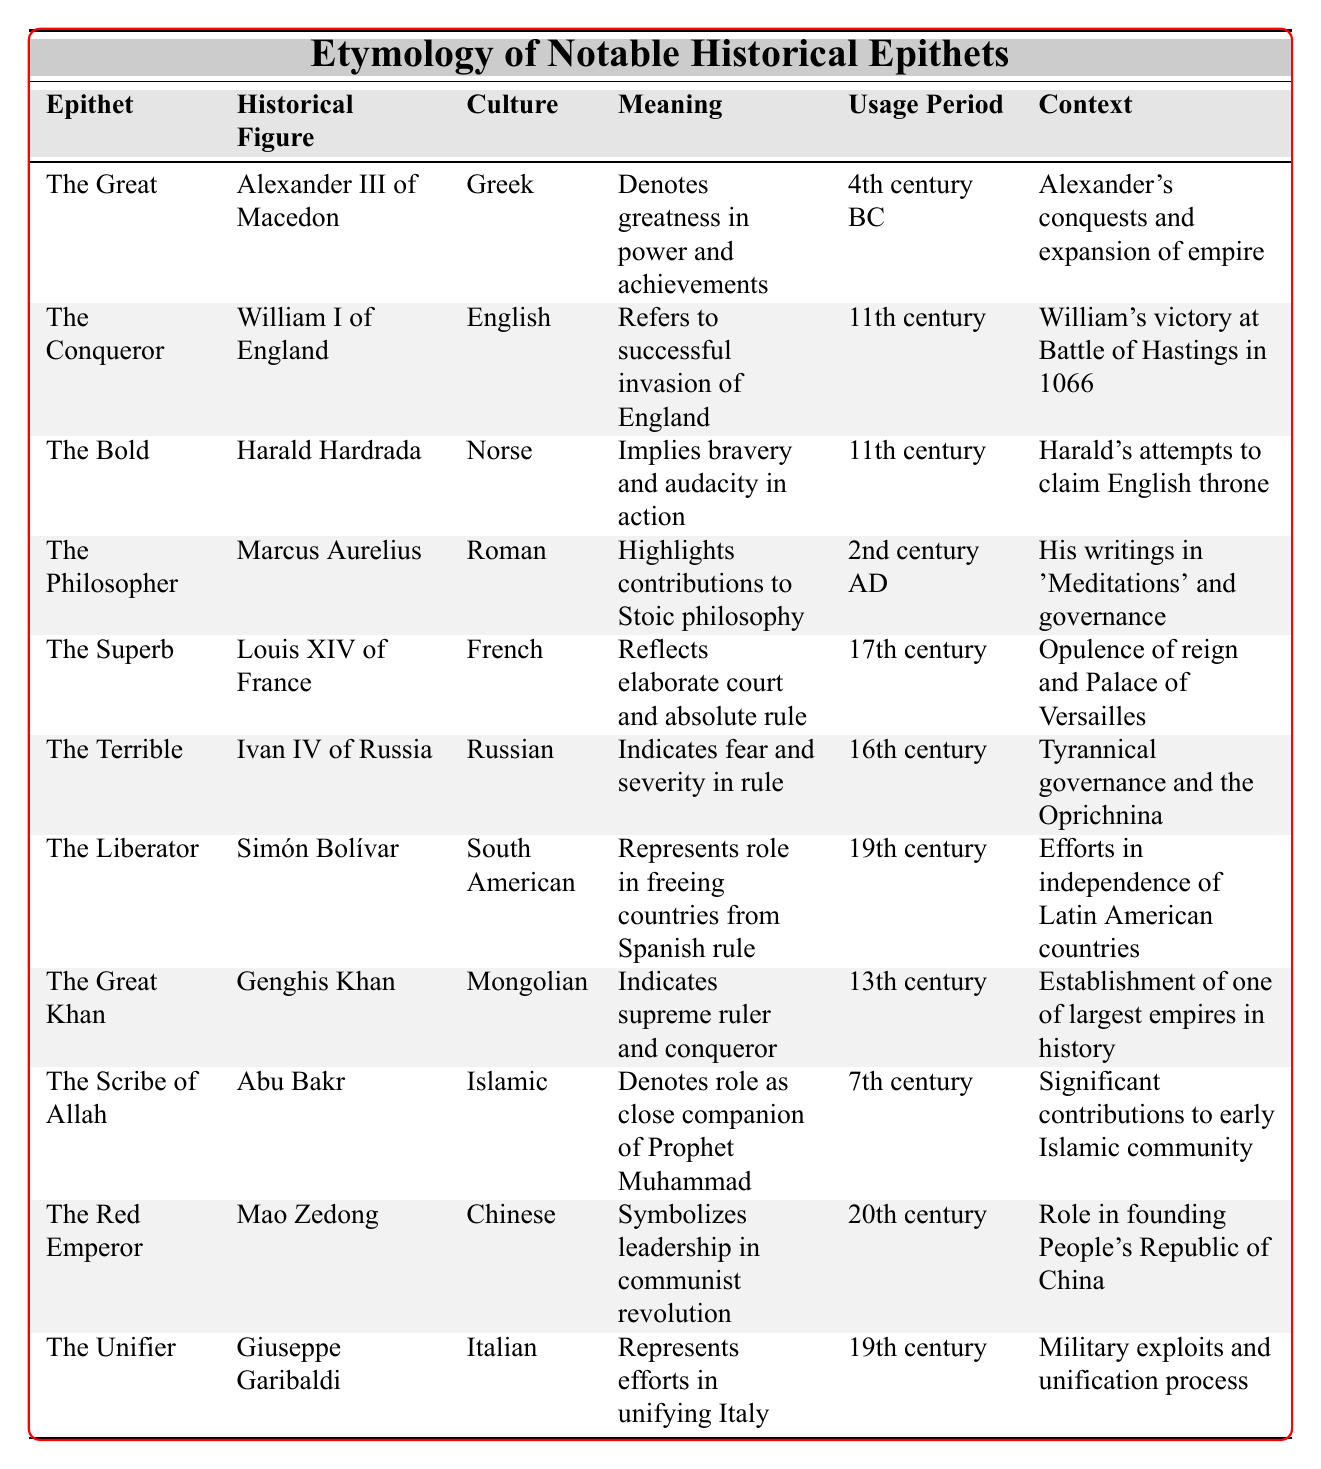What is the epithet associated with Alexander III of Macedon? The table shows that Alexander III of Macedon is associated with the epithet "The Great."
Answer: The Great Which culture is associated with the epithet "The Terrible"? The table indicates that the epithet "The Terrible" is associated with Russian culture, specifically in relation to Ivan IV of Russia.
Answer: Russian What does the epithet "The Unifier" mean? According to the table, "The Unifier" represents Giuseppe Garibaldi's efforts in unifying Italy.
Answer: Efforts in unifying Italy How many epithets are listed in the table? By counting the rows in the table, there are a total of 10 epithets listed.
Answer: 10 Which historical figure's epithet reflects his contributions to Stoic philosophy? The table specifies that Marcus Aurelius is known as "The Philosopher," which reflects his contributions to Stoic philosophy.
Answer: Marcus Aurelius Is "The Red Emperor" associated with a 20th-century historical figure? The table shows that "The Red Emperor" refers to Mao Zedong, and he is indeed a 20th-century historical figure.
Answer: Yes What is the meaning of "The Philopher"? The epithet "The Philosopher" highlights Marcus Aurelius' contributions to Stoic philosophy, as indicated in the table.
Answer: Contributions to Stoic philosophy Which two epithets are associated with figures from the 11th century? The table lists "The Conqueror" for William I of England and "The Bold" for Harald Hardrada as the two epithets from the 11th century.
Answer: The Conqueror, The Bold What is the context for the epithet "The Superb"? The context provided in the table shows that "The Superb" refers to the opulence of Louis XIV's reign and the Palace of Versailles.
Answer: Opulence of Louis XIV's reign Who was referred to as "The Liberator"? The table indicates that Simón Bolívar was referred to as "The Liberator," due to his role in freeing multiple countries from Spanish rule.
Answer: Simón Bolívar What does "The Great Khan" imply about Genghis Khan? According to the table, "The Great Khan" indicates that Genghis Khan was seen as a supreme ruler and conqueror, reflecting his historical significance.
Answer: Supreme ruler and conqueror Which epithet is associated with a close companion of the Prophet Muhammad? "The Scribe of Allah" is the epithet associated with Abu Bakr, noted as a close companion of the Prophet Muhammad in the table.
Answer: The Scribe of Allah How many epithets listed are from the 19th century? Based on the table, there are three epithets associated with the 19th century: "The Liberator," "The Unifier," and Simón Bolívar's efforts in Latin America's independence.
Answer: 3 Is "The Bold" associated with a Norse historical figure? Yes, the table confirms that "The Bold" refers to Harald Hardrada, a Norse historical figure.
Answer: Yes Which figure was known for his elaborate court during the 17th century? The table identifies Louis XIV of France as known for his elaborate court and is referred to as "The Superb," corresponding to the 17th century.
Answer: Louis XIV of France What is the meaning of "The Terrible"? The table elucidates that "The Terrible" indicates fear and severity in the rule of Ivan IV of Russia.
Answer: Fear and severity in rule 